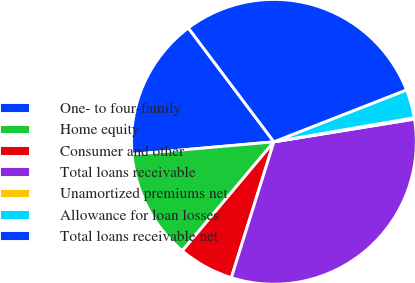Convert chart to OTSL. <chart><loc_0><loc_0><loc_500><loc_500><pie_chart><fcel>One- to four-family<fcel>Home equity<fcel>Consumer and other<fcel>Total loans receivable<fcel>Unamortized premiums net<fcel>Allowance for loan losses<fcel>Total loans receivable net<nl><fcel>16.15%<fcel>12.47%<fcel>6.29%<fcel>32.38%<fcel>0.16%<fcel>3.23%<fcel>29.32%<nl></chart> 